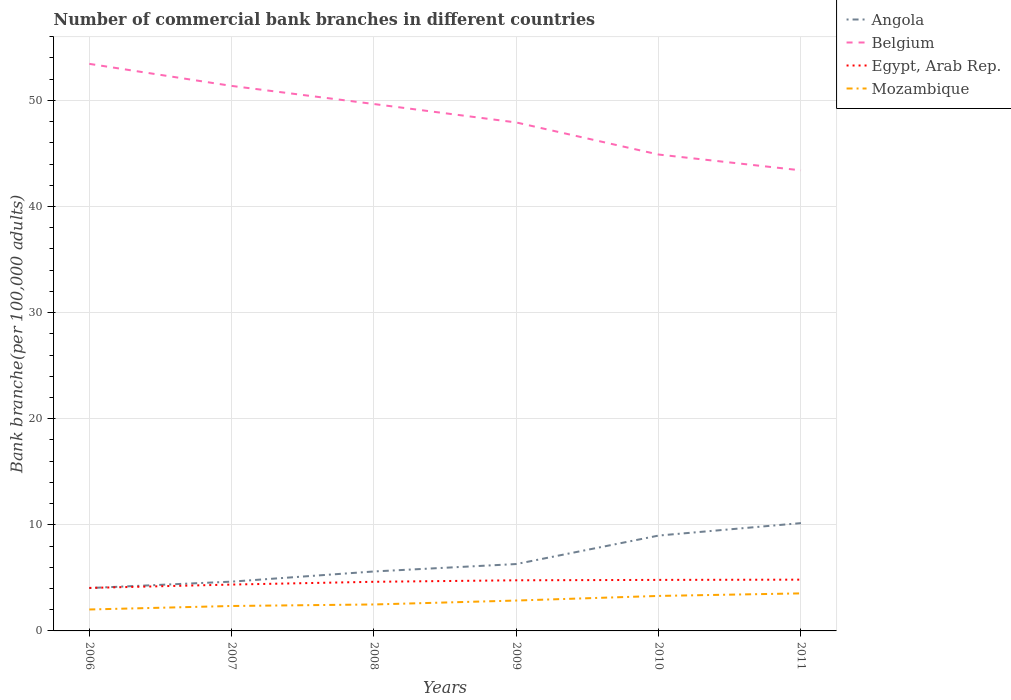Is the number of lines equal to the number of legend labels?
Your response must be concise. Yes. Across all years, what is the maximum number of commercial bank branches in Belgium?
Offer a terse response. 43.4. In which year was the number of commercial bank branches in Egypt, Arab Rep. maximum?
Keep it short and to the point. 2006. What is the total number of commercial bank branches in Egypt, Arab Rep. in the graph?
Provide a short and direct response. -0.46. What is the difference between the highest and the second highest number of commercial bank branches in Egypt, Arab Rep.?
Ensure brevity in your answer.  0.78. What is the difference between the highest and the lowest number of commercial bank branches in Mozambique?
Offer a terse response. 3. How many lines are there?
Give a very brief answer. 4. Are the values on the major ticks of Y-axis written in scientific E-notation?
Offer a terse response. No. Does the graph contain any zero values?
Your answer should be compact. No. Where does the legend appear in the graph?
Your answer should be very brief. Top right. How many legend labels are there?
Your answer should be very brief. 4. How are the legend labels stacked?
Provide a short and direct response. Vertical. What is the title of the graph?
Offer a terse response. Number of commercial bank branches in different countries. Does "Kazakhstan" appear as one of the legend labels in the graph?
Provide a succinct answer. No. What is the label or title of the Y-axis?
Provide a succinct answer. Bank branche(per 100,0 adults). What is the Bank branche(per 100,000 adults) of Angola in 2006?
Offer a terse response. 4.04. What is the Bank branche(per 100,000 adults) of Belgium in 2006?
Ensure brevity in your answer.  53.44. What is the Bank branche(per 100,000 adults) in Egypt, Arab Rep. in 2006?
Your answer should be compact. 4.05. What is the Bank branche(per 100,000 adults) in Mozambique in 2006?
Offer a very short reply. 2.02. What is the Bank branche(per 100,000 adults) of Angola in 2007?
Make the answer very short. 4.64. What is the Bank branche(per 100,000 adults) of Belgium in 2007?
Ensure brevity in your answer.  51.36. What is the Bank branche(per 100,000 adults) in Egypt, Arab Rep. in 2007?
Offer a very short reply. 4.37. What is the Bank branche(per 100,000 adults) of Mozambique in 2007?
Provide a short and direct response. 2.35. What is the Bank branche(per 100,000 adults) of Angola in 2008?
Provide a succinct answer. 5.6. What is the Bank branche(per 100,000 adults) in Belgium in 2008?
Keep it short and to the point. 49.65. What is the Bank branche(per 100,000 adults) in Egypt, Arab Rep. in 2008?
Offer a terse response. 4.63. What is the Bank branche(per 100,000 adults) of Mozambique in 2008?
Your answer should be very brief. 2.49. What is the Bank branche(per 100,000 adults) of Angola in 2009?
Provide a short and direct response. 6.3. What is the Bank branche(per 100,000 adults) in Belgium in 2009?
Your answer should be compact. 47.92. What is the Bank branche(per 100,000 adults) in Egypt, Arab Rep. in 2009?
Keep it short and to the point. 4.77. What is the Bank branche(per 100,000 adults) in Mozambique in 2009?
Your answer should be very brief. 2.86. What is the Bank branche(per 100,000 adults) in Angola in 2010?
Make the answer very short. 8.99. What is the Bank branche(per 100,000 adults) of Belgium in 2010?
Give a very brief answer. 44.89. What is the Bank branche(per 100,000 adults) of Egypt, Arab Rep. in 2010?
Provide a short and direct response. 4.81. What is the Bank branche(per 100,000 adults) of Mozambique in 2010?
Offer a terse response. 3.3. What is the Bank branche(per 100,000 adults) of Angola in 2011?
Make the answer very short. 10.16. What is the Bank branche(per 100,000 adults) of Belgium in 2011?
Keep it short and to the point. 43.4. What is the Bank branche(per 100,000 adults) of Egypt, Arab Rep. in 2011?
Keep it short and to the point. 4.83. What is the Bank branche(per 100,000 adults) of Mozambique in 2011?
Ensure brevity in your answer.  3.54. Across all years, what is the maximum Bank branche(per 100,000 adults) of Angola?
Your answer should be compact. 10.16. Across all years, what is the maximum Bank branche(per 100,000 adults) in Belgium?
Your answer should be very brief. 53.44. Across all years, what is the maximum Bank branche(per 100,000 adults) in Egypt, Arab Rep.?
Your response must be concise. 4.83. Across all years, what is the maximum Bank branche(per 100,000 adults) of Mozambique?
Keep it short and to the point. 3.54. Across all years, what is the minimum Bank branche(per 100,000 adults) of Angola?
Your answer should be very brief. 4.04. Across all years, what is the minimum Bank branche(per 100,000 adults) of Belgium?
Provide a succinct answer. 43.4. Across all years, what is the minimum Bank branche(per 100,000 adults) in Egypt, Arab Rep.?
Provide a succinct answer. 4.05. Across all years, what is the minimum Bank branche(per 100,000 adults) in Mozambique?
Give a very brief answer. 2.02. What is the total Bank branche(per 100,000 adults) of Angola in the graph?
Keep it short and to the point. 39.74. What is the total Bank branche(per 100,000 adults) in Belgium in the graph?
Offer a very short reply. 290.67. What is the total Bank branche(per 100,000 adults) of Egypt, Arab Rep. in the graph?
Ensure brevity in your answer.  27.46. What is the total Bank branche(per 100,000 adults) of Mozambique in the graph?
Offer a terse response. 16.56. What is the difference between the Bank branche(per 100,000 adults) of Angola in 2006 and that in 2007?
Offer a very short reply. -0.6. What is the difference between the Bank branche(per 100,000 adults) in Belgium in 2006 and that in 2007?
Give a very brief answer. 2.08. What is the difference between the Bank branche(per 100,000 adults) of Egypt, Arab Rep. in 2006 and that in 2007?
Your answer should be very brief. -0.32. What is the difference between the Bank branche(per 100,000 adults) in Mozambique in 2006 and that in 2007?
Your answer should be compact. -0.33. What is the difference between the Bank branche(per 100,000 adults) of Angola in 2006 and that in 2008?
Offer a terse response. -1.56. What is the difference between the Bank branche(per 100,000 adults) of Belgium in 2006 and that in 2008?
Ensure brevity in your answer.  3.79. What is the difference between the Bank branche(per 100,000 adults) in Egypt, Arab Rep. in 2006 and that in 2008?
Your answer should be very brief. -0.58. What is the difference between the Bank branche(per 100,000 adults) of Mozambique in 2006 and that in 2008?
Your answer should be very brief. -0.47. What is the difference between the Bank branche(per 100,000 adults) of Angola in 2006 and that in 2009?
Ensure brevity in your answer.  -2.26. What is the difference between the Bank branche(per 100,000 adults) of Belgium in 2006 and that in 2009?
Keep it short and to the point. 5.52. What is the difference between the Bank branche(per 100,000 adults) in Egypt, Arab Rep. in 2006 and that in 2009?
Ensure brevity in your answer.  -0.72. What is the difference between the Bank branche(per 100,000 adults) in Mozambique in 2006 and that in 2009?
Provide a succinct answer. -0.84. What is the difference between the Bank branche(per 100,000 adults) of Angola in 2006 and that in 2010?
Offer a very short reply. -4.95. What is the difference between the Bank branche(per 100,000 adults) in Belgium in 2006 and that in 2010?
Give a very brief answer. 8.55. What is the difference between the Bank branche(per 100,000 adults) of Egypt, Arab Rep. in 2006 and that in 2010?
Provide a short and direct response. -0.76. What is the difference between the Bank branche(per 100,000 adults) of Mozambique in 2006 and that in 2010?
Your response must be concise. -1.28. What is the difference between the Bank branche(per 100,000 adults) of Angola in 2006 and that in 2011?
Provide a succinct answer. -6.12. What is the difference between the Bank branche(per 100,000 adults) of Belgium in 2006 and that in 2011?
Keep it short and to the point. 10.04. What is the difference between the Bank branche(per 100,000 adults) of Egypt, Arab Rep. in 2006 and that in 2011?
Your response must be concise. -0.78. What is the difference between the Bank branche(per 100,000 adults) of Mozambique in 2006 and that in 2011?
Offer a terse response. -1.52. What is the difference between the Bank branche(per 100,000 adults) in Angola in 2007 and that in 2008?
Give a very brief answer. -0.96. What is the difference between the Bank branche(per 100,000 adults) in Belgium in 2007 and that in 2008?
Your answer should be very brief. 1.71. What is the difference between the Bank branche(per 100,000 adults) in Egypt, Arab Rep. in 2007 and that in 2008?
Provide a succinct answer. -0.26. What is the difference between the Bank branche(per 100,000 adults) of Mozambique in 2007 and that in 2008?
Your answer should be very brief. -0.14. What is the difference between the Bank branche(per 100,000 adults) of Angola in 2007 and that in 2009?
Offer a very short reply. -1.66. What is the difference between the Bank branche(per 100,000 adults) of Belgium in 2007 and that in 2009?
Provide a short and direct response. 3.44. What is the difference between the Bank branche(per 100,000 adults) in Egypt, Arab Rep. in 2007 and that in 2009?
Ensure brevity in your answer.  -0.4. What is the difference between the Bank branche(per 100,000 adults) in Mozambique in 2007 and that in 2009?
Offer a terse response. -0.51. What is the difference between the Bank branche(per 100,000 adults) in Angola in 2007 and that in 2010?
Make the answer very short. -4.34. What is the difference between the Bank branche(per 100,000 adults) in Belgium in 2007 and that in 2010?
Your answer should be compact. 6.47. What is the difference between the Bank branche(per 100,000 adults) in Egypt, Arab Rep. in 2007 and that in 2010?
Your response must be concise. -0.44. What is the difference between the Bank branche(per 100,000 adults) of Mozambique in 2007 and that in 2010?
Keep it short and to the point. -0.95. What is the difference between the Bank branche(per 100,000 adults) in Angola in 2007 and that in 2011?
Your answer should be compact. -5.52. What is the difference between the Bank branche(per 100,000 adults) of Belgium in 2007 and that in 2011?
Offer a terse response. 7.96. What is the difference between the Bank branche(per 100,000 adults) in Egypt, Arab Rep. in 2007 and that in 2011?
Give a very brief answer. -0.46. What is the difference between the Bank branche(per 100,000 adults) in Mozambique in 2007 and that in 2011?
Keep it short and to the point. -1.19. What is the difference between the Bank branche(per 100,000 adults) of Angola in 2008 and that in 2009?
Provide a short and direct response. -0.7. What is the difference between the Bank branche(per 100,000 adults) of Belgium in 2008 and that in 2009?
Make the answer very short. 1.74. What is the difference between the Bank branche(per 100,000 adults) of Egypt, Arab Rep. in 2008 and that in 2009?
Make the answer very short. -0.14. What is the difference between the Bank branche(per 100,000 adults) of Mozambique in 2008 and that in 2009?
Offer a very short reply. -0.37. What is the difference between the Bank branche(per 100,000 adults) of Angola in 2008 and that in 2010?
Your answer should be very brief. -3.38. What is the difference between the Bank branche(per 100,000 adults) in Belgium in 2008 and that in 2010?
Ensure brevity in your answer.  4.76. What is the difference between the Bank branche(per 100,000 adults) in Egypt, Arab Rep. in 2008 and that in 2010?
Make the answer very short. -0.18. What is the difference between the Bank branche(per 100,000 adults) in Mozambique in 2008 and that in 2010?
Provide a succinct answer. -0.8. What is the difference between the Bank branche(per 100,000 adults) in Angola in 2008 and that in 2011?
Provide a short and direct response. -4.56. What is the difference between the Bank branche(per 100,000 adults) of Belgium in 2008 and that in 2011?
Give a very brief answer. 6.25. What is the difference between the Bank branche(per 100,000 adults) in Egypt, Arab Rep. in 2008 and that in 2011?
Give a very brief answer. -0.2. What is the difference between the Bank branche(per 100,000 adults) in Mozambique in 2008 and that in 2011?
Your response must be concise. -1.04. What is the difference between the Bank branche(per 100,000 adults) of Angola in 2009 and that in 2010?
Provide a short and direct response. -2.68. What is the difference between the Bank branche(per 100,000 adults) of Belgium in 2009 and that in 2010?
Your response must be concise. 3.02. What is the difference between the Bank branche(per 100,000 adults) in Egypt, Arab Rep. in 2009 and that in 2010?
Provide a succinct answer. -0.04. What is the difference between the Bank branche(per 100,000 adults) of Mozambique in 2009 and that in 2010?
Offer a terse response. -0.43. What is the difference between the Bank branche(per 100,000 adults) of Angola in 2009 and that in 2011?
Give a very brief answer. -3.86. What is the difference between the Bank branche(per 100,000 adults) in Belgium in 2009 and that in 2011?
Your answer should be compact. 4.51. What is the difference between the Bank branche(per 100,000 adults) in Egypt, Arab Rep. in 2009 and that in 2011?
Offer a very short reply. -0.06. What is the difference between the Bank branche(per 100,000 adults) in Mozambique in 2009 and that in 2011?
Your answer should be compact. -0.67. What is the difference between the Bank branche(per 100,000 adults) of Angola in 2010 and that in 2011?
Provide a short and direct response. -1.17. What is the difference between the Bank branche(per 100,000 adults) in Belgium in 2010 and that in 2011?
Provide a short and direct response. 1.49. What is the difference between the Bank branche(per 100,000 adults) in Egypt, Arab Rep. in 2010 and that in 2011?
Your response must be concise. -0.02. What is the difference between the Bank branche(per 100,000 adults) of Mozambique in 2010 and that in 2011?
Offer a very short reply. -0.24. What is the difference between the Bank branche(per 100,000 adults) in Angola in 2006 and the Bank branche(per 100,000 adults) in Belgium in 2007?
Provide a succinct answer. -47.32. What is the difference between the Bank branche(per 100,000 adults) in Angola in 2006 and the Bank branche(per 100,000 adults) in Egypt, Arab Rep. in 2007?
Offer a very short reply. -0.33. What is the difference between the Bank branche(per 100,000 adults) of Angola in 2006 and the Bank branche(per 100,000 adults) of Mozambique in 2007?
Your answer should be compact. 1.69. What is the difference between the Bank branche(per 100,000 adults) of Belgium in 2006 and the Bank branche(per 100,000 adults) of Egypt, Arab Rep. in 2007?
Offer a very short reply. 49.07. What is the difference between the Bank branche(per 100,000 adults) in Belgium in 2006 and the Bank branche(per 100,000 adults) in Mozambique in 2007?
Provide a succinct answer. 51.09. What is the difference between the Bank branche(per 100,000 adults) of Egypt, Arab Rep. in 2006 and the Bank branche(per 100,000 adults) of Mozambique in 2007?
Keep it short and to the point. 1.7. What is the difference between the Bank branche(per 100,000 adults) of Angola in 2006 and the Bank branche(per 100,000 adults) of Belgium in 2008?
Provide a short and direct response. -45.61. What is the difference between the Bank branche(per 100,000 adults) in Angola in 2006 and the Bank branche(per 100,000 adults) in Egypt, Arab Rep. in 2008?
Provide a short and direct response. -0.59. What is the difference between the Bank branche(per 100,000 adults) of Angola in 2006 and the Bank branche(per 100,000 adults) of Mozambique in 2008?
Ensure brevity in your answer.  1.55. What is the difference between the Bank branche(per 100,000 adults) in Belgium in 2006 and the Bank branche(per 100,000 adults) in Egypt, Arab Rep. in 2008?
Ensure brevity in your answer.  48.81. What is the difference between the Bank branche(per 100,000 adults) in Belgium in 2006 and the Bank branche(per 100,000 adults) in Mozambique in 2008?
Offer a terse response. 50.95. What is the difference between the Bank branche(per 100,000 adults) in Egypt, Arab Rep. in 2006 and the Bank branche(per 100,000 adults) in Mozambique in 2008?
Keep it short and to the point. 1.56. What is the difference between the Bank branche(per 100,000 adults) in Angola in 2006 and the Bank branche(per 100,000 adults) in Belgium in 2009?
Your answer should be compact. -43.88. What is the difference between the Bank branche(per 100,000 adults) in Angola in 2006 and the Bank branche(per 100,000 adults) in Egypt, Arab Rep. in 2009?
Your answer should be very brief. -0.73. What is the difference between the Bank branche(per 100,000 adults) in Angola in 2006 and the Bank branche(per 100,000 adults) in Mozambique in 2009?
Offer a terse response. 1.18. What is the difference between the Bank branche(per 100,000 adults) of Belgium in 2006 and the Bank branche(per 100,000 adults) of Egypt, Arab Rep. in 2009?
Your response must be concise. 48.67. What is the difference between the Bank branche(per 100,000 adults) of Belgium in 2006 and the Bank branche(per 100,000 adults) of Mozambique in 2009?
Your answer should be compact. 50.58. What is the difference between the Bank branche(per 100,000 adults) of Egypt, Arab Rep. in 2006 and the Bank branche(per 100,000 adults) of Mozambique in 2009?
Keep it short and to the point. 1.19. What is the difference between the Bank branche(per 100,000 adults) of Angola in 2006 and the Bank branche(per 100,000 adults) of Belgium in 2010?
Give a very brief answer. -40.85. What is the difference between the Bank branche(per 100,000 adults) in Angola in 2006 and the Bank branche(per 100,000 adults) in Egypt, Arab Rep. in 2010?
Offer a terse response. -0.77. What is the difference between the Bank branche(per 100,000 adults) in Angola in 2006 and the Bank branche(per 100,000 adults) in Mozambique in 2010?
Ensure brevity in your answer.  0.74. What is the difference between the Bank branche(per 100,000 adults) in Belgium in 2006 and the Bank branche(per 100,000 adults) in Egypt, Arab Rep. in 2010?
Provide a short and direct response. 48.63. What is the difference between the Bank branche(per 100,000 adults) in Belgium in 2006 and the Bank branche(per 100,000 adults) in Mozambique in 2010?
Your answer should be compact. 50.14. What is the difference between the Bank branche(per 100,000 adults) in Egypt, Arab Rep. in 2006 and the Bank branche(per 100,000 adults) in Mozambique in 2010?
Your answer should be compact. 0.75. What is the difference between the Bank branche(per 100,000 adults) in Angola in 2006 and the Bank branche(per 100,000 adults) in Belgium in 2011?
Make the answer very short. -39.36. What is the difference between the Bank branche(per 100,000 adults) in Angola in 2006 and the Bank branche(per 100,000 adults) in Egypt, Arab Rep. in 2011?
Your answer should be compact. -0.79. What is the difference between the Bank branche(per 100,000 adults) in Angola in 2006 and the Bank branche(per 100,000 adults) in Mozambique in 2011?
Offer a very short reply. 0.5. What is the difference between the Bank branche(per 100,000 adults) of Belgium in 2006 and the Bank branche(per 100,000 adults) of Egypt, Arab Rep. in 2011?
Keep it short and to the point. 48.61. What is the difference between the Bank branche(per 100,000 adults) in Belgium in 2006 and the Bank branche(per 100,000 adults) in Mozambique in 2011?
Your answer should be very brief. 49.9. What is the difference between the Bank branche(per 100,000 adults) of Egypt, Arab Rep. in 2006 and the Bank branche(per 100,000 adults) of Mozambique in 2011?
Ensure brevity in your answer.  0.51. What is the difference between the Bank branche(per 100,000 adults) of Angola in 2007 and the Bank branche(per 100,000 adults) of Belgium in 2008?
Provide a short and direct response. -45.01. What is the difference between the Bank branche(per 100,000 adults) in Angola in 2007 and the Bank branche(per 100,000 adults) in Egypt, Arab Rep. in 2008?
Your response must be concise. 0.01. What is the difference between the Bank branche(per 100,000 adults) of Angola in 2007 and the Bank branche(per 100,000 adults) of Mozambique in 2008?
Offer a very short reply. 2.15. What is the difference between the Bank branche(per 100,000 adults) in Belgium in 2007 and the Bank branche(per 100,000 adults) in Egypt, Arab Rep. in 2008?
Your response must be concise. 46.73. What is the difference between the Bank branche(per 100,000 adults) in Belgium in 2007 and the Bank branche(per 100,000 adults) in Mozambique in 2008?
Offer a very short reply. 48.87. What is the difference between the Bank branche(per 100,000 adults) in Egypt, Arab Rep. in 2007 and the Bank branche(per 100,000 adults) in Mozambique in 2008?
Give a very brief answer. 1.88. What is the difference between the Bank branche(per 100,000 adults) of Angola in 2007 and the Bank branche(per 100,000 adults) of Belgium in 2009?
Your answer should be compact. -43.27. What is the difference between the Bank branche(per 100,000 adults) in Angola in 2007 and the Bank branche(per 100,000 adults) in Egypt, Arab Rep. in 2009?
Offer a terse response. -0.13. What is the difference between the Bank branche(per 100,000 adults) of Angola in 2007 and the Bank branche(per 100,000 adults) of Mozambique in 2009?
Offer a terse response. 1.78. What is the difference between the Bank branche(per 100,000 adults) of Belgium in 2007 and the Bank branche(per 100,000 adults) of Egypt, Arab Rep. in 2009?
Provide a succinct answer. 46.59. What is the difference between the Bank branche(per 100,000 adults) in Belgium in 2007 and the Bank branche(per 100,000 adults) in Mozambique in 2009?
Give a very brief answer. 48.5. What is the difference between the Bank branche(per 100,000 adults) of Egypt, Arab Rep. in 2007 and the Bank branche(per 100,000 adults) of Mozambique in 2009?
Your response must be concise. 1.5. What is the difference between the Bank branche(per 100,000 adults) of Angola in 2007 and the Bank branche(per 100,000 adults) of Belgium in 2010?
Your answer should be very brief. -40.25. What is the difference between the Bank branche(per 100,000 adults) of Angola in 2007 and the Bank branche(per 100,000 adults) of Egypt, Arab Rep. in 2010?
Ensure brevity in your answer.  -0.16. What is the difference between the Bank branche(per 100,000 adults) of Angola in 2007 and the Bank branche(per 100,000 adults) of Mozambique in 2010?
Ensure brevity in your answer.  1.35. What is the difference between the Bank branche(per 100,000 adults) in Belgium in 2007 and the Bank branche(per 100,000 adults) in Egypt, Arab Rep. in 2010?
Your response must be concise. 46.55. What is the difference between the Bank branche(per 100,000 adults) of Belgium in 2007 and the Bank branche(per 100,000 adults) of Mozambique in 2010?
Make the answer very short. 48.06. What is the difference between the Bank branche(per 100,000 adults) in Egypt, Arab Rep. in 2007 and the Bank branche(per 100,000 adults) in Mozambique in 2010?
Keep it short and to the point. 1.07. What is the difference between the Bank branche(per 100,000 adults) in Angola in 2007 and the Bank branche(per 100,000 adults) in Belgium in 2011?
Give a very brief answer. -38.76. What is the difference between the Bank branche(per 100,000 adults) in Angola in 2007 and the Bank branche(per 100,000 adults) in Egypt, Arab Rep. in 2011?
Provide a succinct answer. -0.19. What is the difference between the Bank branche(per 100,000 adults) of Angola in 2007 and the Bank branche(per 100,000 adults) of Mozambique in 2011?
Keep it short and to the point. 1.11. What is the difference between the Bank branche(per 100,000 adults) in Belgium in 2007 and the Bank branche(per 100,000 adults) in Egypt, Arab Rep. in 2011?
Provide a short and direct response. 46.53. What is the difference between the Bank branche(per 100,000 adults) of Belgium in 2007 and the Bank branche(per 100,000 adults) of Mozambique in 2011?
Give a very brief answer. 47.82. What is the difference between the Bank branche(per 100,000 adults) in Egypt, Arab Rep. in 2007 and the Bank branche(per 100,000 adults) in Mozambique in 2011?
Give a very brief answer. 0.83. What is the difference between the Bank branche(per 100,000 adults) in Angola in 2008 and the Bank branche(per 100,000 adults) in Belgium in 2009?
Make the answer very short. -42.31. What is the difference between the Bank branche(per 100,000 adults) in Angola in 2008 and the Bank branche(per 100,000 adults) in Egypt, Arab Rep. in 2009?
Your response must be concise. 0.83. What is the difference between the Bank branche(per 100,000 adults) of Angola in 2008 and the Bank branche(per 100,000 adults) of Mozambique in 2009?
Offer a terse response. 2.74. What is the difference between the Bank branche(per 100,000 adults) in Belgium in 2008 and the Bank branche(per 100,000 adults) in Egypt, Arab Rep. in 2009?
Your response must be concise. 44.88. What is the difference between the Bank branche(per 100,000 adults) of Belgium in 2008 and the Bank branche(per 100,000 adults) of Mozambique in 2009?
Your answer should be very brief. 46.79. What is the difference between the Bank branche(per 100,000 adults) of Egypt, Arab Rep. in 2008 and the Bank branche(per 100,000 adults) of Mozambique in 2009?
Provide a succinct answer. 1.77. What is the difference between the Bank branche(per 100,000 adults) in Angola in 2008 and the Bank branche(per 100,000 adults) in Belgium in 2010?
Make the answer very short. -39.29. What is the difference between the Bank branche(per 100,000 adults) in Angola in 2008 and the Bank branche(per 100,000 adults) in Egypt, Arab Rep. in 2010?
Ensure brevity in your answer.  0.8. What is the difference between the Bank branche(per 100,000 adults) in Angola in 2008 and the Bank branche(per 100,000 adults) in Mozambique in 2010?
Your answer should be compact. 2.31. What is the difference between the Bank branche(per 100,000 adults) in Belgium in 2008 and the Bank branche(per 100,000 adults) in Egypt, Arab Rep. in 2010?
Make the answer very short. 44.85. What is the difference between the Bank branche(per 100,000 adults) in Belgium in 2008 and the Bank branche(per 100,000 adults) in Mozambique in 2010?
Give a very brief answer. 46.36. What is the difference between the Bank branche(per 100,000 adults) in Egypt, Arab Rep. in 2008 and the Bank branche(per 100,000 adults) in Mozambique in 2010?
Provide a succinct answer. 1.33. What is the difference between the Bank branche(per 100,000 adults) of Angola in 2008 and the Bank branche(per 100,000 adults) of Belgium in 2011?
Offer a terse response. -37.8. What is the difference between the Bank branche(per 100,000 adults) in Angola in 2008 and the Bank branche(per 100,000 adults) in Egypt, Arab Rep. in 2011?
Provide a short and direct response. 0.77. What is the difference between the Bank branche(per 100,000 adults) in Angola in 2008 and the Bank branche(per 100,000 adults) in Mozambique in 2011?
Offer a very short reply. 2.07. What is the difference between the Bank branche(per 100,000 adults) of Belgium in 2008 and the Bank branche(per 100,000 adults) of Egypt, Arab Rep. in 2011?
Offer a terse response. 44.82. What is the difference between the Bank branche(per 100,000 adults) of Belgium in 2008 and the Bank branche(per 100,000 adults) of Mozambique in 2011?
Offer a very short reply. 46.12. What is the difference between the Bank branche(per 100,000 adults) in Egypt, Arab Rep. in 2008 and the Bank branche(per 100,000 adults) in Mozambique in 2011?
Offer a terse response. 1.09. What is the difference between the Bank branche(per 100,000 adults) in Angola in 2009 and the Bank branche(per 100,000 adults) in Belgium in 2010?
Keep it short and to the point. -38.59. What is the difference between the Bank branche(per 100,000 adults) of Angola in 2009 and the Bank branche(per 100,000 adults) of Egypt, Arab Rep. in 2010?
Keep it short and to the point. 1.49. What is the difference between the Bank branche(per 100,000 adults) in Angola in 2009 and the Bank branche(per 100,000 adults) in Mozambique in 2010?
Keep it short and to the point. 3. What is the difference between the Bank branche(per 100,000 adults) of Belgium in 2009 and the Bank branche(per 100,000 adults) of Egypt, Arab Rep. in 2010?
Your answer should be compact. 43.11. What is the difference between the Bank branche(per 100,000 adults) of Belgium in 2009 and the Bank branche(per 100,000 adults) of Mozambique in 2010?
Offer a very short reply. 44.62. What is the difference between the Bank branche(per 100,000 adults) of Egypt, Arab Rep. in 2009 and the Bank branche(per 100,000 adults) of Mozambique in 2010?
Your answer should be very brief. 1.47. What is the difference between the Bank branche(per 100,000 adults) in Angola in 2009 and the Bank branche(per 100,000 adults) in Belgium in 2011?
Keep it short and to the point. -37.1. What is the difference between the Bank branche(per 100,000 adults) of Angola in 2009 and the Bank branche(per 100,000 adults) of Egypt, Arab Rep. in 2011?
Your response must be concise. 1.47. What is the difference between the Bank branche(per 100,000 adults) in Angola in 2009 and the Bank branche(per 100,000 adults) in Mozambique in 2011?
Your answer should be compact. 2.77. What is the difference between the Bank branche(per 100,000 adults) in Belgium in 2009 and the Bank branche(per 100,000 adults) in Egypt, Arab Rep. in 2011?
Your response must be concise. 43.08. What is the difference between the Bank branche(per 100,000 adults) of Belgium in 2009 and the Bank branche(per 100,000 adults) of Mozambique in 2011?
Provide a succinct answer. 44.38. What is the difference between the Bank branche(per 100,000 adults) of Egypt, Arab Rep. in 2009 and the Bank branche(per 100,000 adults) of Mozambique in 2011?
Your response must be concise. 1.23. What is the difference between the Bank branche(per 100,000 adults) in Angola in 2010 and the Bank branche(per 100,000 adults) in Belgium in 2011?
Ensure brevity in your answer.  -34.42. What is the difference between the Bank branche(per 100,000 adults) of Angola in 2010 and the Bank branche(per 100,000 adults) of Egypt, Arab Rep. in 2011?
Make the answer very short. 4.16. What is the difference between the Bank branche(per 100,000 adults) in Angola in 2010 and the Bank branche(per 100,000 adults) in Mozambique in 2011?
Offer a terse response. 5.45. What is the difference between the Bank branche(per 100,000 adults) in Belgium in 2010 and the Bank branche(per 100,000 adults) in Egypt, Arab Rep. in 2011?
Offer a very short reply. 40.06. What is the difference between the Bank branche(per 100,000 adults) in Belgium in 2010 and the Bank branche(per 100,000 adults) in Mozambique in 2011?
Provide a short and direct response. 41.36. What is the difference between the Bank branche(per 100,000 adults) in Egypt, Arab Rep. in 2010 and the Bank branche(per 100,000 adults) in Mozambique in 2011?
Offer a terse response. 1.27. What is the average Bank branche(per 100,000 adults) of Angola per year?
Provide a succinct answer. 6.62. What is the average Bank branche(per 100,000 adults) in Belgium per year?
Your response must be concise. 48.44. What is the average Bank branche(per 100,000 adults) in Egypt, Arab Rep. per year?
Keep it short and to the point. 4.58. What is the average Bank branche(per 100,000 adults) in Mozambique per year?
Provide a succinct answer. 2.76. In the year 2006, what is the difference between the Bank branche(per 100,000 adults) in Angola and Bank branche(per 100,000 adults) in Belgium?
Ensure brevity in your answer.  -49.4. In the year 2006, what is the difference between the Bank branche(per 100,000 adults) of Angola and Bank branche(per 100,000 adults) of Egypt, Arab Rep.?
Offer a very short reply. -0.01. In the year 2006, what is the difference between the Bank branche(per 100,000 adults) of Angola and Bank branche(per 100,000 adults) of Mozambique?
Your answer should be compact. 2.02. In the year 2006, what is the difference between the Bank branche(per 100,000 adults) in Belgium and Bank branche(per 100,000 adults) in Egypt, Arab Rep.?
Offer a very short reply. 49.39. In the year 2006, what is the difference between the Bank branche(per 100,000 adults) in Belgium and Bank branche(per 100,000 adults) in Mozambique?
Provide a short and direct response. 51.42. In the year 2006, what is the difference between the Bank branche(per 100,000 adults) in Egypt, Arab Rep. and Bank branche(per 100,000 adults) in Mozambique?
Provide a succinct answer. 2.03. In the year 2007, what is the difference between the Bank branche(per 100,000 adults) of Angola and Bank branche(per 100,000 adults) of Belgium?
Ensure brevity in your answer.  -46.72. In the year 2007, what is the difference between the Bank branche(per 100,000 adults) of Angola and Bank branche(per 100,000 adults) of Egypt, Arab Rep.?
Offer a terse response. 0.28. In the year 2007, what is the difference between the Bank branche(per 100,000 adults) in Angola and Bank branche(per 100,000 adults) in Mozambique?
Offer a terse response. 2.3. In the year 2007, what is the difference between the Bank branche(per 100,000 adults) of Belgium and Bank branche(per 100,000 adults) of Egypt, Arab Rep.?
Offer a terse response. 46.99. In the year 2007, what is the difference between the Bank branche(per 100,000 adults) of Belgium and Bank branche(per 100,000 adults) of Mozambique?
Make the answer very short. 49.01. In the year 2007, what is the difference between the Bank branche(per 100,000 adults) in Egypt, Arab Rep. and Bank branche(per 100,000 adults) in Mozambique?
Offer a very short reply. 2.02. In the year 2008, what is the difference between the Bank branche(per 100,000 adults) in Angola and Bank branche(per 100,000 adults) in Belgium?
Ensure brevity in your answer.  -44.05. In the year 2008, what is the difference between the Bank branche(per 100,000 adults) of Angola and Bank branche(per 100,000 adults) of Egypt, Arab Rep.?
Give a very brief answer. 0.97. In the year 2008, what is the difference between the Bank branche(per 100,000 adults) in Angola and Bank branche(per 100,000 adults) in Mozambique?
Give a very brief answer. 3.11. In the year 2008, what is the difference between the Bank branche(per 100,000 adults) of Belgium and Bank branche(per 100,000 adults) of Egypt, Arab Rep.?
Keep it short and to the point. 45.02. In the year 2008, what is the difference between the Bank branche(per 100,000 adults) in Belgium and Bank branche(per 100,000 adults) in Mozambique?
Your answer should be compact. 47.16. In the year 2008, what is the difference between the Bank branche(per 100,000 adults) of Egypt, Arab Rep. and Bank branche(per 100,000 adults) of Mozambique?
Provide a succinct answer. 2.14. In the year 2009, what is the difference between the Bank branche(per 100,000 adults) in Angola and Bank branche(per 100,000 adults) in Belgium?
Offer a terse response. -41.61. In the year 2009, what is the difference between the Bank branche(per 100,000 adults) of Angola and Bank branche(per 100,000 adults) of Egypt, Arab Rep.?
Keep it short and to the point. 1.53. In the year 2009, what is the difference between the Bank branche(per 100,000 adults) in Angola and Bank branche(per 100,000 adults) in Mozambique?
Offer a very short reply. 3.44. In the year 2009, what is the difference between the Bank branche(per 100,000 adults) of Belgium and Bank branche(per 100,000 adults) of Egypt, Arab Rep.?
Provide a succinct answer. 43.14. In the year 2009, what is the difference between the Bank branche(per 100,000 adults) in Belgium and Bank branche(per 100,000 adults) in Mozambique?
Your response must be concise. 45.05. In the year 2009, what is the difference between the Bank branche(per 100,000 adults) in Egypt, Arab Rep. and Bank branche(per 100,000 adults) in Mozambique?
Provide a succinct answer. 1.91. In the year 2010, what is the difference between the Bank branche(per 100,000 adults) in Angola and Bank branche(per 100,000 adults) in Belgium?
Your answer should be very brief. -35.91. In the year 2010, what is the difference between the Bank branche(per 100,000 adults) of Angola and Bank branche(per 100,000 adults) of Egypt, Arab Rep.?
Offer a very short reply. 4.18. In the year 2010, what is the difference between the Bank branche(per 100,000 adults) of Angola and Bank branche(per 100,000 adults) of Mozambique?
Offer a very short reply. 5.69. In the year 2010, what is the difference between the Bank branche(per 100,000 adults) of Belgium and Bank branche(per 100,000 adults) of Egypt, Arab Rep.?
Your response must be concise. 40.09. In the year 2010, what is the difference between the Bank branche(per 100,000 adults) of Belgium and Bank branche(per 100,000 adults) of Mozambique?
Make the answer very short. 41.6. In the year 2010, what is the difference between the Bank branche(per 100,000 adults) in Egypt, Arab Rep. and Bank branche(per 100,000 adults) in Mozambique?
Make the answer very short. 1.51. In the year 2011, what is the difference between the Bank branche(per 100,000 adults) of Angola and Bank branche(per 100,000 adults) of Belgium?
Your response must be concise. -33.24. In the year 2011, what is the difference between the Bank branche(per 100,000 adults) in Angola and Bank branche(per 100,000 adults) in Egypt, Arab Rep.?
Offer a very short reply. 5.33. In the year 2011, what is the difference between the Bank branche(per 100,000 adults) of Angola and Bank branche(per 100,000 adults) of Mozambique?
Your response must be concise. 6.62. In the year 2011, what is the difference between the Bank branche(per 100,000 adults) of Belgium and Bank branche(per 100,000 adults) of Egypt, Arab Rep.?
Make the answer very short. 38.57. In the year 2011, what is the difference between the Bank branche(per 100,000 adults) of Belgium and Bank branche(per 100,000 adults) of Mozambique?
Your answer should be compact. 39.87. In the year 2011, what is the difference between the Bank branche(per 100,000 adults) in Egypt, Arab Rep. and Bank branche(per 100,000 adults) in Mozambique?
Give a very brief answer. 1.29. What is the ratio of the Bank branche(per 100,000 adults) in Angola in 2006 to that in 2007?
Your response must be concise. 0.87. What is the ratio of the Bank branche(per 100,000 adults) in Belgium in 2006 to that in 2007?
Make the answer very short. 1.04. What is the ratio of the Bank branche(per 100,000 adults) in Egypt, Arab Rep. in 2006 to that in 2007?
Provide a succinct answer. 0.93. What is the ratio of the Bank branche(per 100,000 adults) of Mozambique in 2006 to that in 2007?
Ensure brevity in your answer.  0.86. What is the ratio of the Bank branche(per 100,000 adults) in Angola in 2006 to that in 2008?
Your response must be concise. 0.72. What is the ratio of the Bank branche(per 100,000 adults) of Belgium in 2006 to that in 2008?
Ensure brevity in your answer.  1.08. What is the ratio of the Bank branche(per 100,000 adults) of Egypt, Arab Rep. in 2006 to that in 2008?
Provide a succinct answer. 0.88. What is the ratio of the Bank branche(per 100,000 adults) of Mozambique in 2006 to that in 2008?
Offer a very short reply. 0.81. What is the ratio of the Bank branche(per 100,000 adults) of Angola in 2006 to that in 2009?
Offer a very short reply. 0.64. What is the ratio of the Bank branche(per 100,000 adults) of Belgium in 2006 to that in 2009?
Ensure brevity in your answer.  1.12. What is the ratio of the Bank branche(per 100,000 adults) of Egypt, Arab Rep. in 2006 to that in 2009?
Offer a very short reply. 0.85. What is the ratio of the Bank branche(per 100,000 adults) in Mozambique in 2006 to that in 2009?
Keep it short and to the point. 0.71. What is the ratio of the Bank branche(per 100,000 adults) in Angola in 2006 to that in 2010?
Your answer should be very brief. 0.45. What is the ratio of the Bank branche(per 100,000 adults) in Belgium in 2006 to that in 2010?
Provide a short and direct response. 1.19. What is the ratio of the Bank branche(per 100,000 adults) of Egypt, Arab Rep. in 2006 to that in 2010?
Ensure brevity in your answer.  0.84. What is the ratio of the Bank branche(per 100,000 adults) in Mozambique in 2006 to that in 2010?
Provide a succinct answer. 0.61. What is the ratio of the Bank branche(per 100,000 adults) of Angola in 2006 to that in 2011?
Provide a short and direct response. 0.4. What is the ratio of the Bank branche(per 100,000 adults) in Belgium in 2006 to that in 2011?
Your answer should be very brief. 1.23. What is the ratio of the Bank branche(per 100,000 adults) in Egypt, Arab Rep. in 2006 to that in 2011?
Ensure brevity in your answer.  0.84. What is the ratio of the Bank branche(per 100,000 adults) in Mozambique in 2006 to that in 2011?
Offer a terse response. 0.57. What is the ratio of the Bank branche(per 100,000 adults) of Angola in 2007 to that in 2008?
Your response must be concise. 0.83. What is the ratio of the Bank branche(per 100,000 adults) in Belgium in 2007 to that in 2008?
Ensure brevity in your answer.  1.03. What is the ratio of the Bank branche(per 100,000 adults) of Egypt, Arab Rep. in 2007 to that in 2008?
Ensure brevity in your answer.  0.94. What is the ratio of the Bank branche(per 100,000 adults) in Mozambique in 2007 to that in 2008?
Keep it short and to the point. 0.94. What is the ratio of the Bank branche(per 100,000 adults) of Angola in 2007 to that in 2009?
Your response must be concise. 0.74. What is the ratio of the Bank branche(per 100,000 adults) of Belgium in 2007 to that in 2009?
Provide a short and direct response. 1.07. What is the ratio of the Bank branche(per 100,000 adults) of Egypt, Arab Rep. in 2007 to that in 2009?
Provide a short and direct response. 0.92. What is the ratio of the Bank branche(per 100,000 adults) in Mozambique in 2007 to that in 2009?
Your response must be concise. 0.82. What is the ratio of the Bank branche(per 100,000 adults) in Angola in 2007 to that in 2010?
Make the answer very short. 0.52. What is the ratio of the Bank branche(per 100,000 adults) of Belgium in 2007 to that in 2010?
Your answer should be very brief. 1.14. What is the ratio of the Bank branche(per 100,000 adults) in Egypt, Arab Rep. in 2007 to that in 2010?
Your response must be concise. 0.91. What is the ratio of the Bank branche(per 100,000 adults) of Mozambique in 2007 to that in 2010?
Your answer should be compact. 0.71. What is the ratio of the Bank branche(per 100,000 adults) of Angola in 2007 to that in 2011?
Offer a terse response. 0.46. What is the ratio of the Bank branche(per 100,000 adults) of Belgium in 2007 to that in 2011?
Your answer should be very brief. 1.18. What is the ratio of the Bank branche(per 100,000 adults) in Egypt, Arab Rep. in 2007 to that in 2011?
Your answer should be compact. 0.9. What is the ratio of the Bank branche(per 100,000 adults) in Mozambique in 2007 to that in 2011?
Make the answer very short. 0.66. What is the ratio of the Bank branche(per 100,000 adults) of Angola in 2008 to that in 2009?
Offer a terse response. 0.89. What is the ratio of the Bank branche(per 100,000 adults) in Belgium in 2008 to that in 2009?
Your answer should be very brief. 1.04. What is the ratio of the Bank branche(per 100,000 adults) in Egypt, Arab Rep. in 2008 to that in 2009?
Keep it short and to the point. 0.97. What is the ratio of the Bank branche(per 100,000 adults) in Mozambique in 2008 to that in 2009?
Your answer should be very brief. 0.87. What is the ratio of the Bank branche(per 100,000 adults) in Angola in 2008 to that in 2010?
Your answer should be very brief. 0.62. What is the ratio of the Bank branche(per 100,000 adults) in Belgium in 2008 to that in 2010?
Give a very brief answer. 1.11. What is the ratio of the Bank branche(per 100,000 adults) in Egypt, Arab Rep. in 2008 to that in 2010?
Keep it short and to the point. 0.96. What is the ratio of the Bank branche(per 100,000 adults) in Mozambique in 2008 to that in 2010?
Provide a succinct answer. 0.76. What is the ratio of the Bank branche(per 100,000 adults) of Angola in 2008 to that in 2011?
Offer a terse response. 0.55. What is the ratio of the Bank branche(per 100,000 adults) in Belgium in 2008 to that in 2011?
Provide a succinct answer. 1.14. What is the ratio of the Bank branche(per 100,000 adults) in Egypt, Arab Rep. in 2008 to that in 2011?
Give a very brief answer. 0.96. What is the ratio of the Bank branche(per 100,000 adults) of Mozambique in 2008 to that in 2011?
Your response must be concise. 0.7. What is the ratio of the Bank branche(per 100,000 adults) of Angola in 2009 to that in 2010?
Offer a very short reply. 0.7. What is the ratio of the Bank branche(per 100,000 adults) of Belgium in 2009 to that in 2010?
Your response must be concise. 1.07. What is the ratio of the Bank branche(per 100,000 adults) in Mozambique in 2009 to that in 2010?
Ensure brevity in your answer.  0.87. What is the ratio of the Bank branche(per 100,000 adults) of Angola in 2009 to that in 2011?
Give a very brief answer. 0.62. What is the ratio of the Bank branche(per 100,000 adults) of Belgium in 2009 to that in 2011?
Ensure brevity in your answer.  1.1. What is the ratio of the Bank branche(per 100,000 adults) in Egypt, Arab Rep. in 2009 to that in 2011?
Give a very brief answer. 0.99. What is the ratio of the Bank branche(per 100,000 adults) of Mozambique in 2009 to that in 2011?
Provide a short and direct response. 0.81. What is the ratio of the Bank branche(per 100,000 adults) in Angola in 2010 to that in 2011?
Make the answer very short. 0.88. What is the ratio of the Bank branche(per 100,000 adults) of Belgium in 2010 to that in 2011?
Your answer should be very brief. 1.03. What is the ratio of the Bank branche(per 100,000 adults) in Egypt, Arab Rep. in 2010 to that in 2011?
Offer a terse response. 1. What is the ratio of the Bank branche(per 100,000 adults) of Mozambique in 2010 to that in 2011?
Offer a terse response. 0.93. What is the difference between the highest and the second highest Bank branche(per 100,000 adults) of Angola?
Make the answer very short. 1.17. What is the difference between the highest and the second highest Bank branche(per 100,000 adults) of Belgium?
Make the answer very short. 2.08. What is the difference between the highest and the second highest Bank branche(per 100,000 adults) of Egypt, Arab Rep.?
Your answer should be very brief. 0.02. What is the difference between the highest and the second highest Bank branche(per 100,000 adults) in Mozambique?
Give a very brief answer. 0.24. What is the difference between the highest and the lowest Bank branche(per 100,000 adults) of Angola?
Your response must be concise. 6.12. What is the difference between the highest and the lowest Bank branche(per 100,000 adults) in Belgium?
Offer a very short reply. 10.04. What is the difference between the highest and the lowest Bank branche(per 100,000 adults) of Egypt, Arab Rep.?
Your answer should be very brief. 0.78. What is the difference between the highest and the lowest Bank branche(per 100,000 adults) of Mozambique?
Your answer should be very brief. 1.52. 